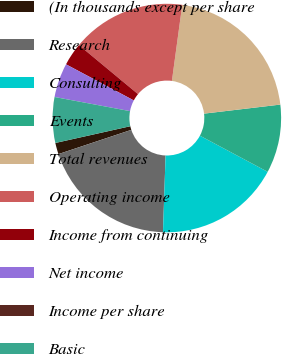Convert chart. <chart><loc_0><loc_0><loc_500><loc_500><pie_chart><fcel>(In thousands except per share<fcel>Research<fcel>Consulting<fcel>Events<fcel>Total revenues<fcel>Operating income<fcel>Income from continuing<fcel>Net income<fcel>Income per share<fcel>Basic<nl><fcel>1.61%<fcel>19.35%<fcel>17.74%<fcel>9.68%<fcel>20.97%<fcel>16.13%<fcel>3.23%<fcel>4.84%<fcel>0.0%<fcel>6.45%<nl></chart> 